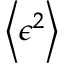<formula> <loc_0><loc_0><loc_500><loc_500>\left \langle \epsilon ^ { 2 } \right \rangle</formula> 